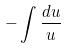<formula> <loc_0><loc_0><loc_500><loc_500>- \int \frac { d u } { u }</formula> 